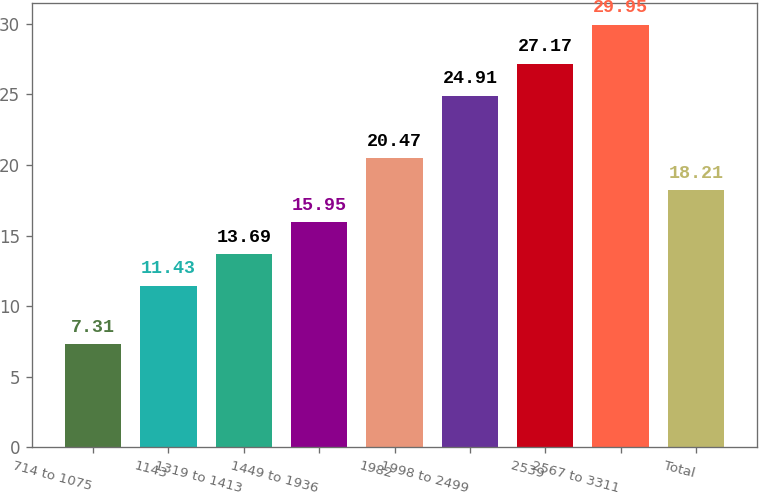Convert chart to OTSL. <chart><loc_0><loc_0><loc_500><loc_500><bar_chart><fcel>714 to 1075<fcel>1143<fcel>1319 to 1413<fcel>1449 to 1936<fcel>1982<fcel>1998 to 2499<fcel>2539<fcel>2567 to 3311<fcel>Total<nl><fcel>7.31<fcel>11.43<fcel>13.69<fcel>15.95<fcel>20.47<fcel>24.91<fcel>27.17<fcel>29.95<fcel>18.21<nl></chart> 